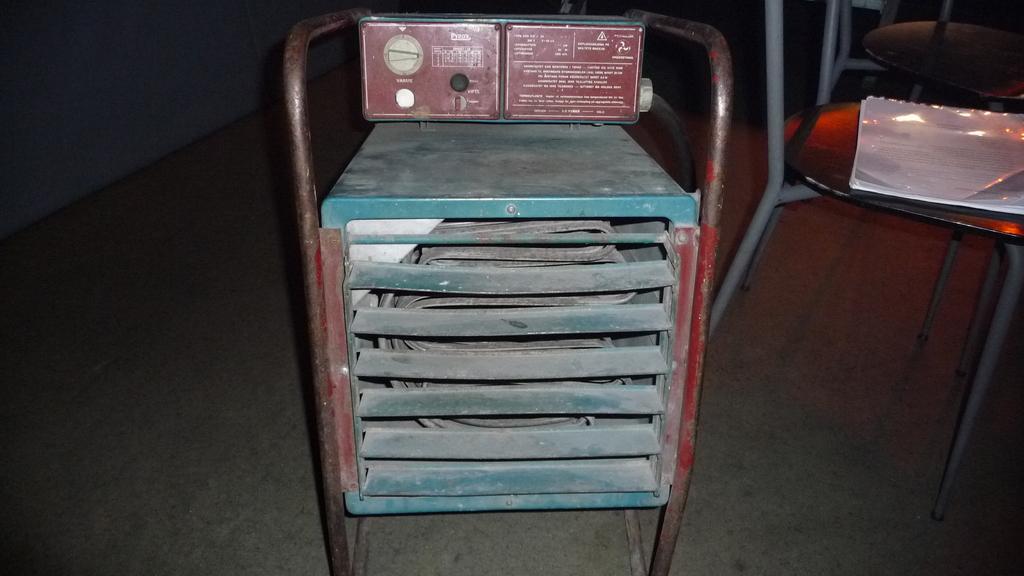Please provide a concise description of this image. In this picture it looks like a metal stand in the front, on the right side there are chairs, we can see a file placed on this chair, there is a dark background. 